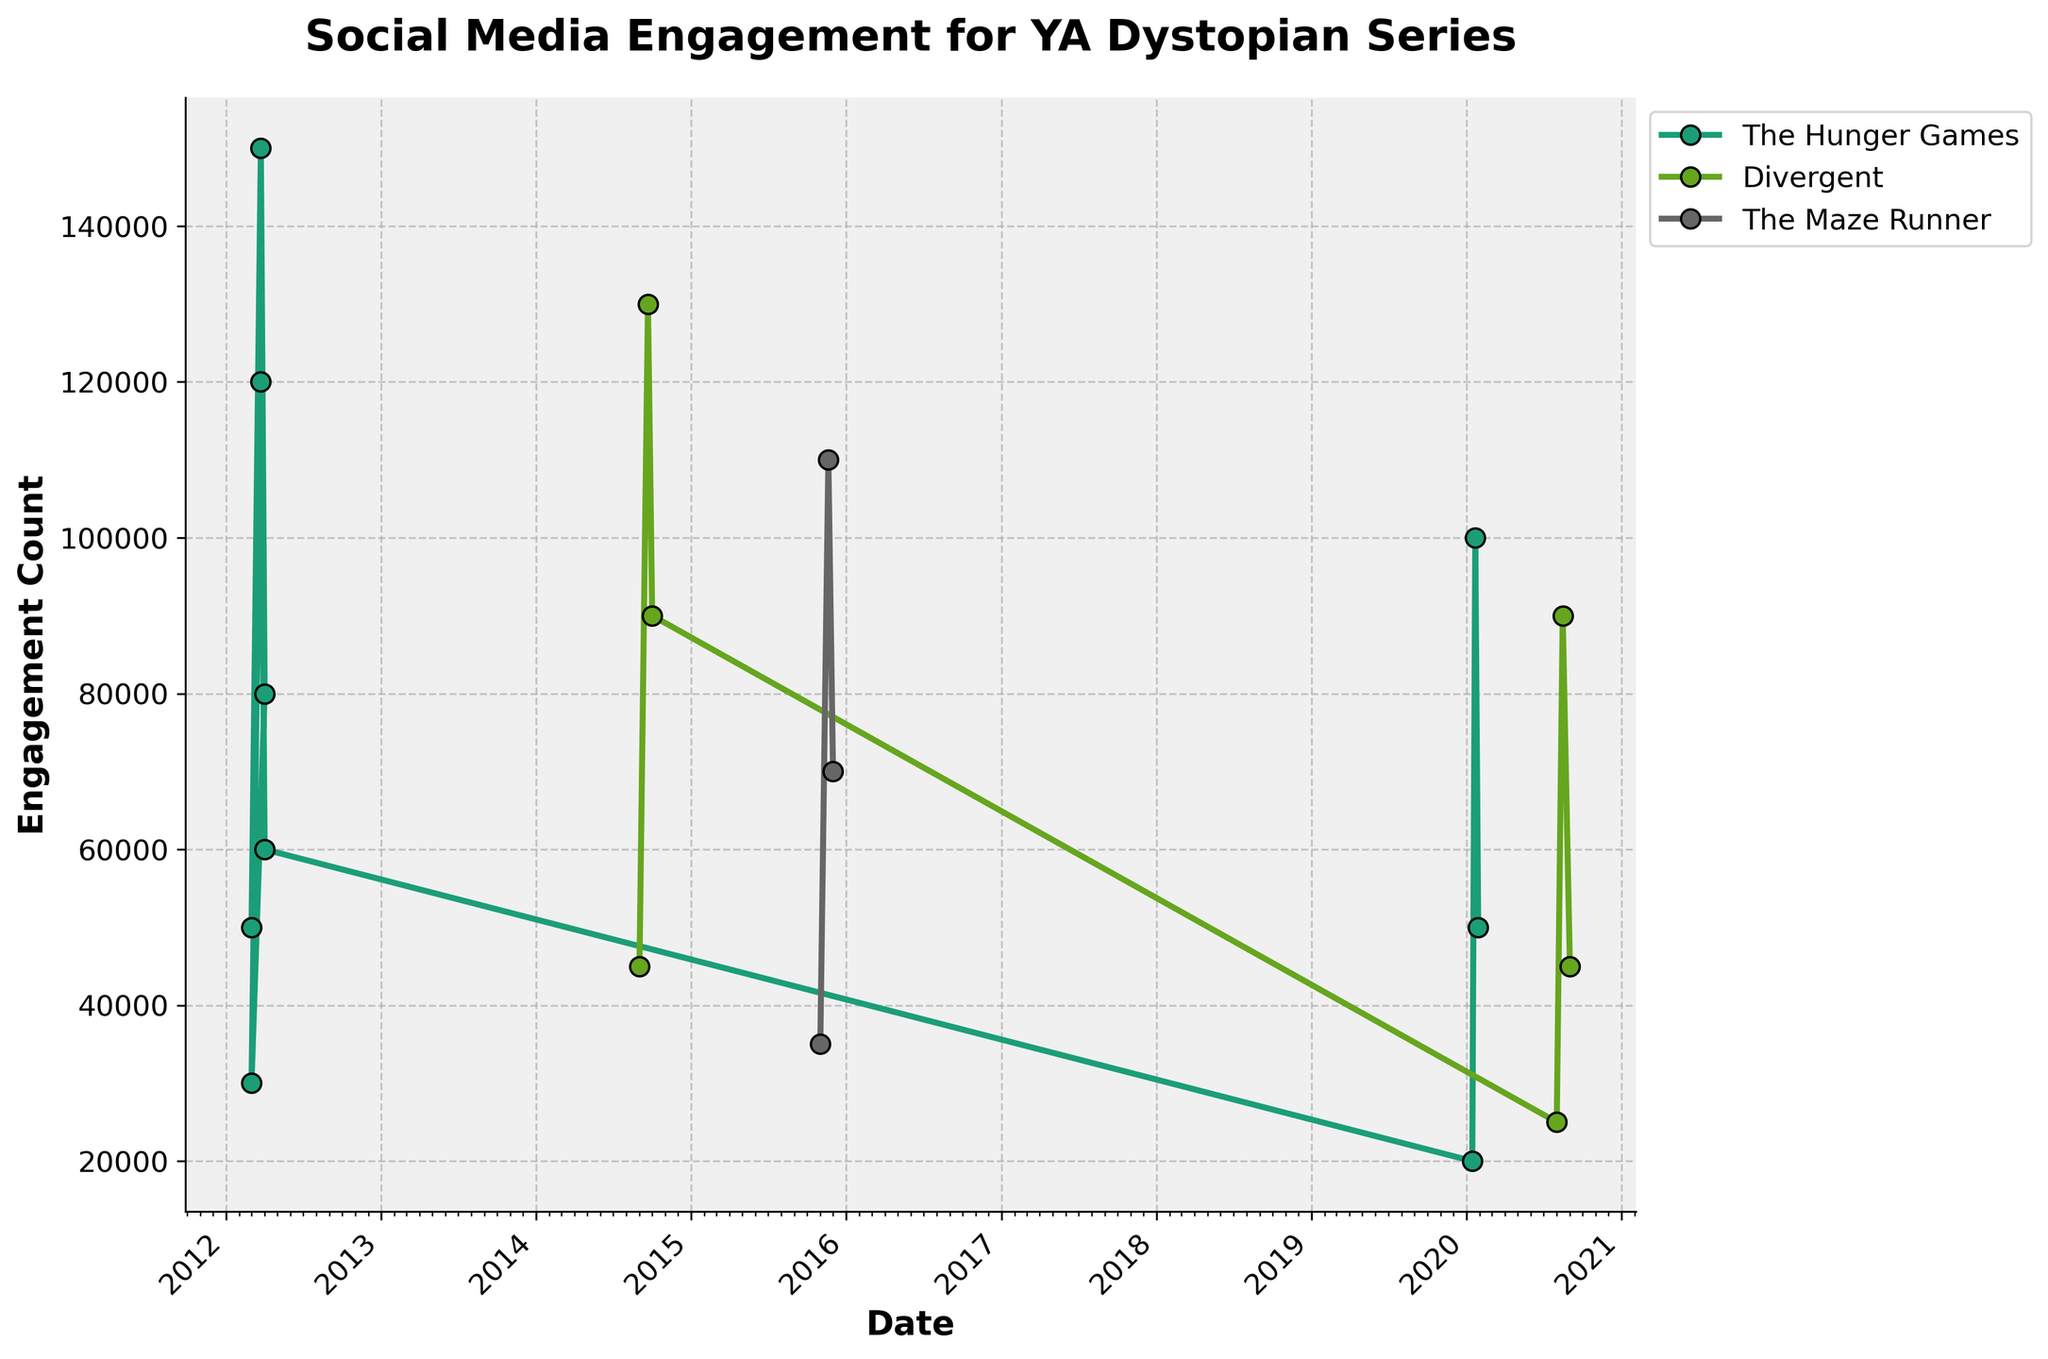What is the title of the plot? The title of the plot is text displayed prominently at the top center, giving an overview of the data being visualized.
Answer: Social Media Engagement for YA Dystopian Series Which series shows engagement spikes in 2012 on Twitter with hashtags? Looking at the plot, we see different colored lines representing each series. The series that spikes in 2012 on Twitter with hashtags is prominent.
Answer: The Hunger Games Which series has the highest engagement count on Instagram in 2014? The plot legend indicates the color for each series. Observing the highest peak in 2014 on the Instagram line reveals the series.
Answer: Divergent What is the engagement count of The Maze Runner on YouTube on November 20, 2015? Locate The Maze Runner series line on the plot, then find the data point for November 20, 2015 and read the engagement count.
Answer: 110,000 Compare the engagement count for The Hunger Games on Facebook just before and after its movie release in March 2012. Locate The Hunger Games series on Facebook in 2012. Compare data points before and after the release in March 2012.
Answer: Before: 30,000, After: 120,000 What is the average engagement count for Divergent on Facebook in 2020? Identify Divergent engagement data on Facebook in 2020 and calculate the average of the counts. \[ (25,000 + 90,000 + 45,000) / 3 = 53,333 \]
Answer: 53,333 Which series shows multiple engagement types on Twitter? Check the plot legend and look for multiple data types on the same platform for one series.
Answer: The Hunger Games Is there a noticeable trend in engagement counts for movie series post-release? Examine the engagement trends post-release for each series, considering if the trend increases or decreases.
Answer: Generally decreases Which series has the least variations in engagement counts on any social media platform? By observing the fluctuations of the lines on the plot, determine which series has the least vertical changes.
Answer: The Maze Runner 